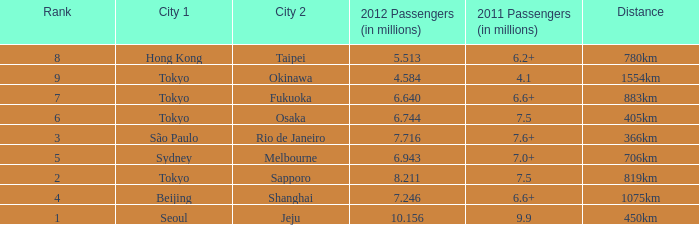How many passengers (in millions) in 2011 flew through along the route that had 6.640 million passengers in 2012? 6.6+. 